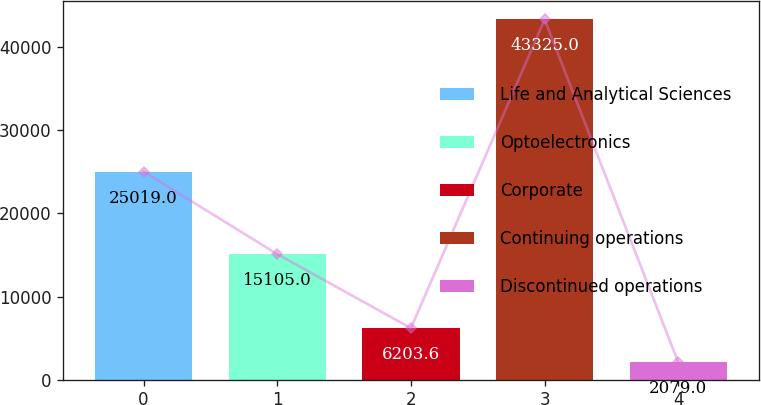Convert chart. <chart><loc_0><loc_0><loc_500><loc_500><bar_chart><fcel>Life and Analytical Sciences<fcel>Optoelectronics<fcel>Corporate<fcel>Continuing operations<fcel>Discontinued operations<nl><fcel>25019<fcel>15105<fcel>6203.6<fcel>43325<fcel>2079<nl></chart> 